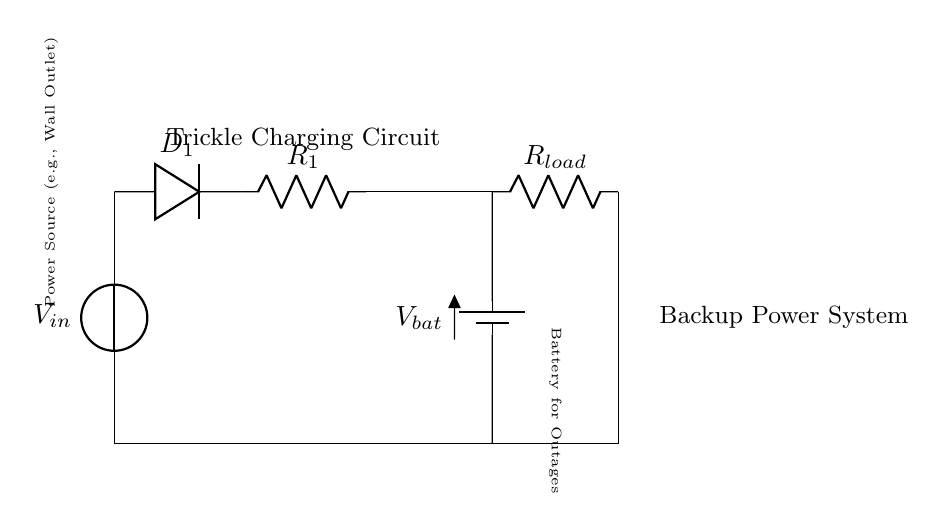What is the main function of the diode in this circuit? The diode allows current to flow in one direction only, preventing backflow and ensuring that the battery is charged properly without discharging back to the power source.
Answer: Allow current in one direction What type of component is R1? R1 is a current limiting resistor that controls the amount of current flowing into the battery during the trickle charging process.
Answer: Current limiting resistor What is the voltage source connected to this circuit? The voltage source is labeled as V_in, which typically represents a power source like a wall outlet providing the necessary voltage for the circuit.
Answer: V_in Which component is responsible for storing energy? The battery, labeled as V_bat, is responsible for storing electrical energy for use during power outages.
Answer: Battery What happens if R1 is eliminated from the circuit? Eliminating R1 would allow uncontrolled current flow into the battery, potentially leading to overcharging, damage, or reduced battery life due to excessive current.
Answer: Uncontrolled current flow What is the load resistor used for in this circuit? The load resistor, labeled as R_load, is used to simulate or represent the power consuming device that would utilize the battery's stored energy when needed.
Answer: Simulate power consumption What type of charging does this circuit use? This circuit uses trickle charging, which involves a low, steady current that charges the battery slowly to maintain its charge without overcharging.
Answer: Trickle charging 